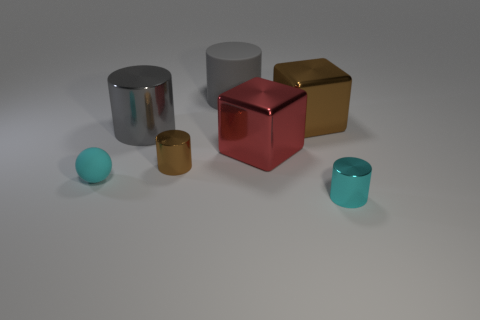What is the texture and lighting like in the scene? The texture of the objects ranges from matte to shiny reflective surfaces. The lighting in the scene is soft and diffused, casting gentle shadows directly beneath the objects, giving a calm and uniform appearance to the setting. 